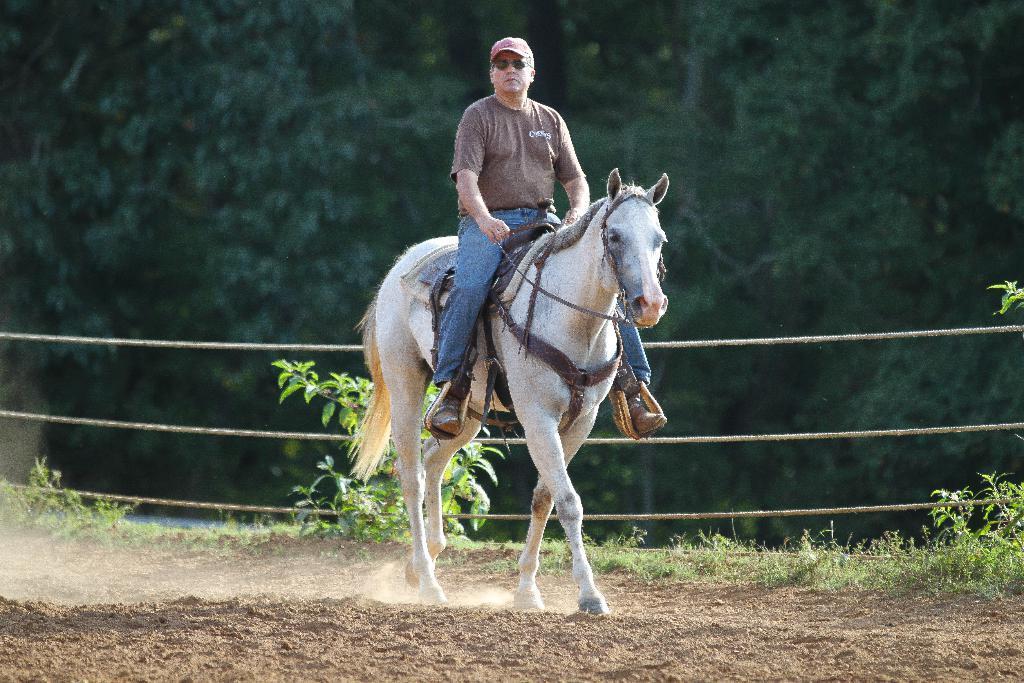Could you give a brief overview of what you see in this image? In this picture we can see a horse walking on the ground with a man sitting on it and he wore a cap and goggles and in the background we can see ropes and trees. 